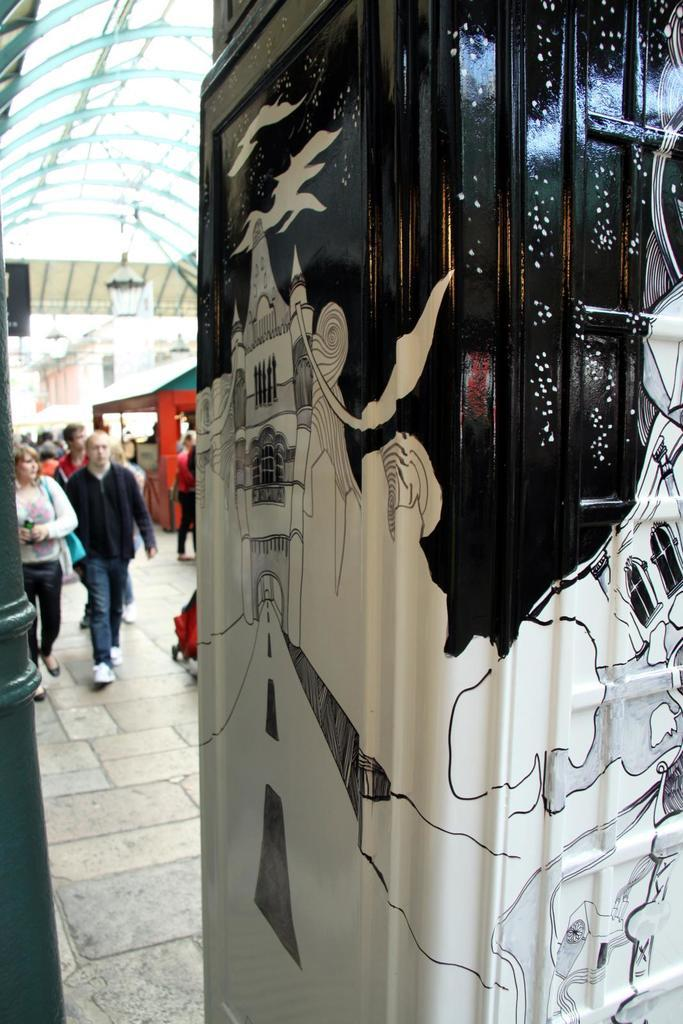What is the main subject of the image? The main subject of the image is a building with a painting. What can be seen on the right side of the image? There is a pole on the right side of the image. What is visible in the background of the image? There are people in the background of the image, and the background appears blurry. What is the position of the fireman in the image? There is no fireman present in the image. How does the painting in the image relate to the flight of a bird? The image does not depict a bird or any flight-related elements, so there is no direct connection between the painting and a bird's flight. 